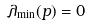<formula> <loc_0><loc_0><loc_500><loc_500>\lambda _ { \min } ( p ) = 0</formula> 